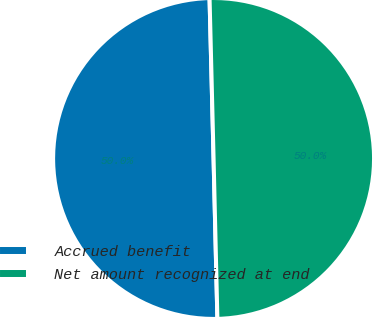<chart> <loc_0><loc_0><loc_500><loc_500><pie_chart><fcel>Accrued benefit<fcel>Net amount recognized at end<nl><fcel>49.98%<fcel>50.02%<nl></chart> 